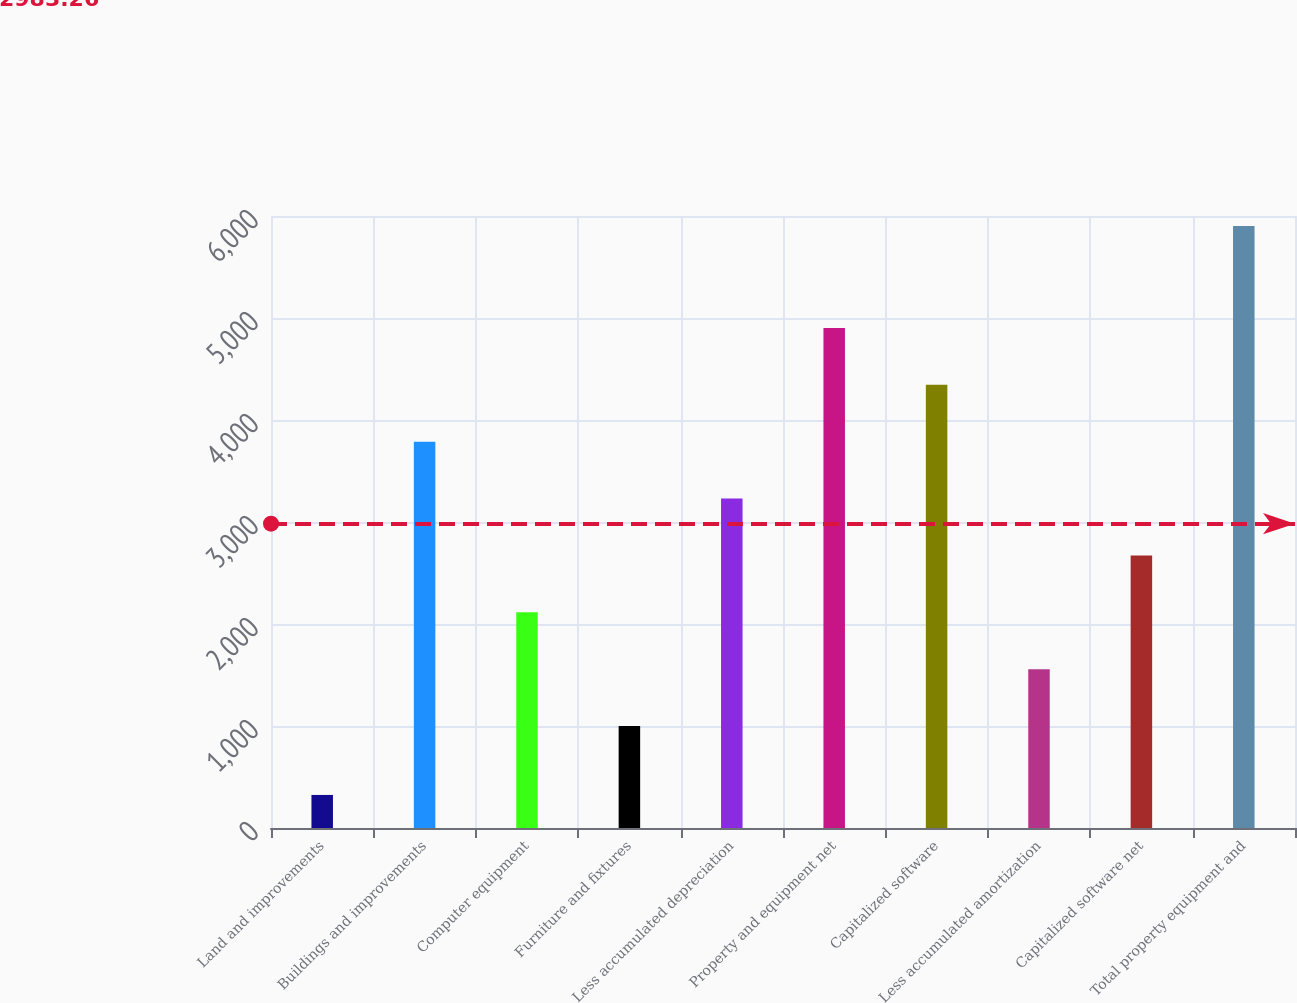<chart> <loc_0><loc_0><loc_500><loc_500><bar_chart><fcel>Land and improvements<fcel>Buildings and improvements<fcel>Computer equipment<fcel>Furniture and fixtures<fcel>Less accumulated depreciation<fcel>Property and equipment net<fcel>Capitalized software<fcel>Less accumulated amortization<fcel>Capitalized software net<fcel>Total property equipment and<nl><fcel>324<fcel>3787.5<fcel>2114.4<fcel>999<fcel>3229.8<fcel>4902.9<fcel>4345.2<fcel>1556.7<fcel>2672.1<fcel>5901<nl></chart> 